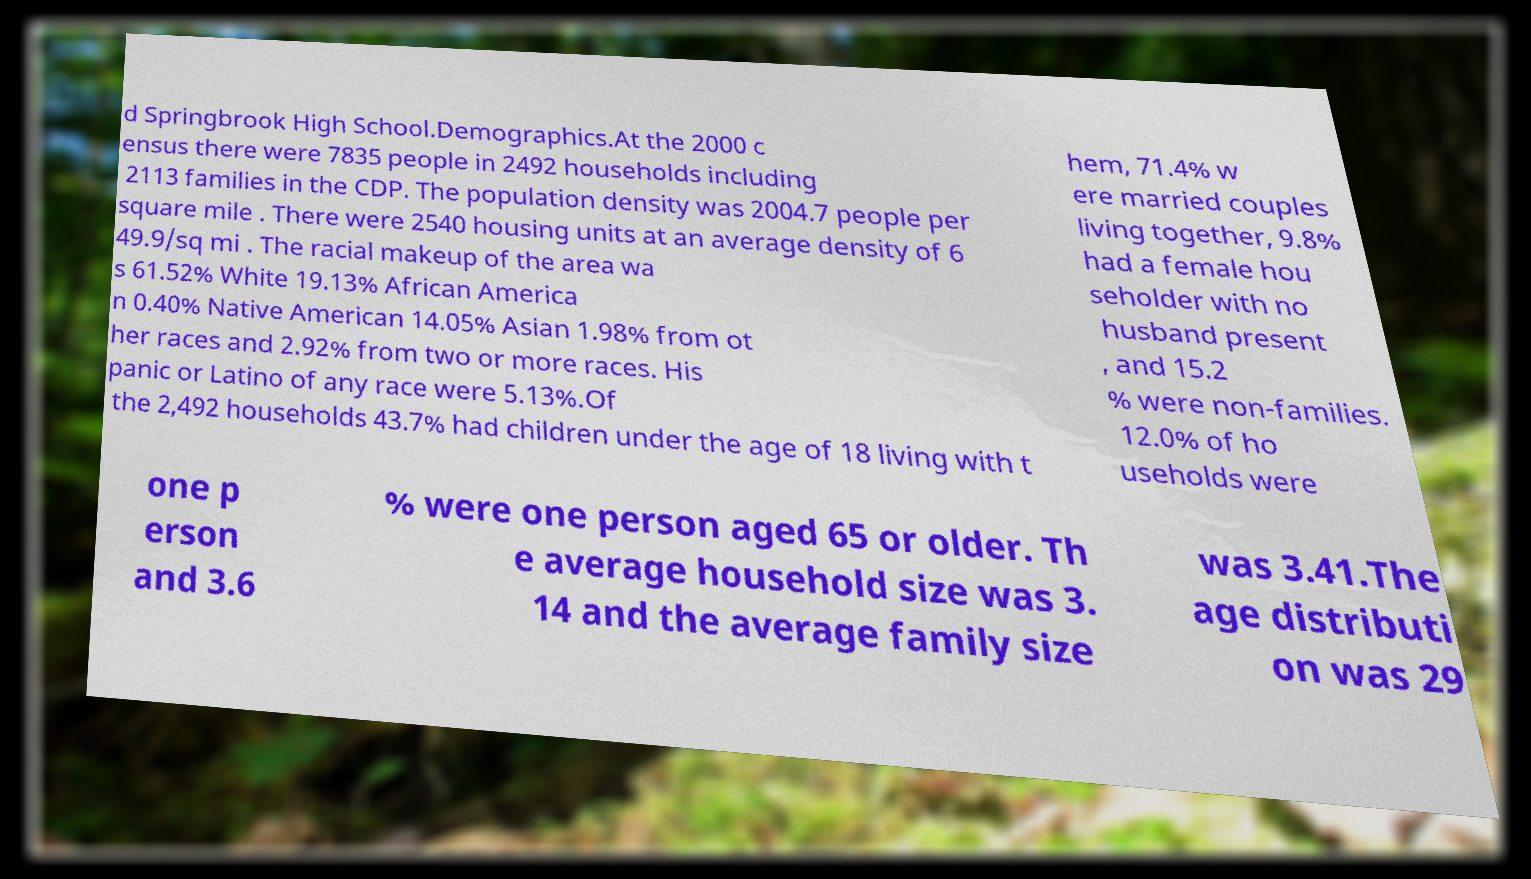For documentation purposes, I need the text within this image transcribed. Could you provide that? d Springbrook High School.Demographics.At the 2000 c ensus there were 7835 people in 2492 households including 2113 families in the CDP. The population density was 2004.7 people per square mile . There were 2540 housing units at an average density of 6 49.9/sq mi . The racial makeup of the area wa s 61.52% White 19.13% African America n 0.40% Native American 14.05% Asian 1.98% from ot her races and 2.92% from two or more races. His panic or Latino of any race were 5.13%.Of the 2,492 households 43.7% had children under the age of 18 living with t hem, 71.4% w ere married couples living together, 9.8% had a female hou seholder with no husband present , and 15.2 % were non-families. 12.0% of ho useholds were one p erson and 3.6 % were one person aged 65 or older. Th e average household size was 3. 14 and the average family size was 3.41.The age distributi on was 29 